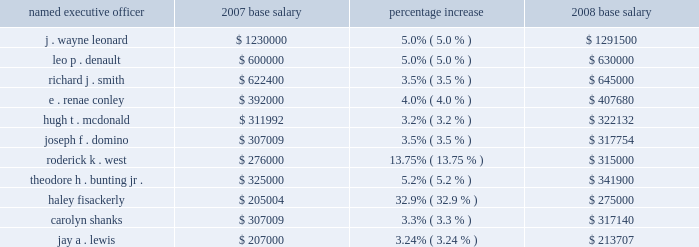The committee's assessment of other elements of compensation provided to the named executive officer .
The corporate and business unit goals and objectives vary by individual officers and include , among other things , corporate and business unit financial performance , capital expenditures , cost containment , safety , reliability , customer service , business development and regulatory matters .
The use of "internal pay equity" in setting merit increases is limited to determining whether a change in an executive officer's role and responsibilities relative to other executive officers requires an adjustment in the officer's salary .
The committee has not established any predetermined formula against which the base salary of one named executive officer is measured against another officer or employee .
In 2008 , on the basis of the market data and other factors described above , merit-based salary increases for the named executive officers were approved in amounts ranging from 3.2 to 5.2 percent .
In general these merit-based increases were consistent with the merit increase percentages approved with respect to named executive officers in the last two years ( excluding adjustments in salaries related to market factors , promotions or other changes in job responsibilities ) .
The table sets forth the 2007 base salaries for the named executive officers , the 2008 percentage increase and the resulting 2008 base salary .
Except as described below , changes in base salaries were effective in april of each of the years shown .
Named executive officer 2007 base salary percentage increase 2008 base salary .
In addition to the market-based and other factors described above , the following factors were considered by the committee with respect to the officers identified below : mr .
Leonard's salary was increased due to the personnel committee's assessment of , among other things , his strong performance as chief executive officer of entergy corporation , entergy corporation's financial and operational performance in 2007 and comparative market data on base salaries for chief executive officers .
In may , 2008 , carolyn shanks resigned as ceo - entergy mississippi and accepted a conditional offer of employment at enexus energy corporation .
Upon her resignation , mr .
Fisackerly was promoted to president and ceo of entergy mississippi , and mr .
Fisackerly's salary was increased to reflect the increased responsibilities of his new position and comparative market and internal data for officers holding similar positions and performing similar responsibilities .
In the third quarter of 2008 , mr .
Bunting took on the role of principal financial officer for the subsidiaries replacing mr .
Lewis in that position .
In the third quarter of 2008 , mr .
Lewis assumed a position with enexus energy corporation .
Mr .
West's salary was increased to reflect his performance as ceo - entergy new orleans , the strategic challenges facing entergy new orleans and the importance of retaining mr .
West to manage these challenges and to retain internal competitiveness of mr .
West's salary with officers in the company holding similar positions. .
What is the difference between the highest and the lowest base salary in 2007? 
Computations: (1230000 - 205004)
Answer: 1024996.0. The committee's assessment of other elements of compensation provided to the named executive officer .
The corporate and business unit goals and objectives vary by individual officers and include , among other things , corporate and business unit financial performance , capital expenditures , cost containment , safety , reliability , customer service , business development and regulatory matters .
The use of "internal pay equity" in setting merit increases is limited to determining whether a change in an executive officer's role and responsibilities relative to other executive officers requires an adjustment in the officer's salary .
The committee has not established any predetermined formula against which the base salary of one named executive officer is measured against another officer or employee .
In 2008 , on the basis of the market data and other factors described above , merit-based salary increases for the named executive officers were approved in amounts ranging from 3.2 to 5.2 percent .
In general these merit-based increases were consistent with the merit increase percentages approved with respect to named executive officers in the last two years ( excluding adjustments in salaries related to market factors , promotions or other changes in job responsibilities ) .
The table sets forth the 2007 base salaries for the named executive officers , the 2008 percentage increase and the resulting 2008 base salary .
Except as described below , changes in base salaries were effective in april of each of the years shown .
Named executive officer 2007 base salary percentage increase 2008 base salary .
In addition to the market-based and other factors described above , the following factors were considered by the committee with respect to the officers identified below : mr .
Leonard's salary was increased due to the personnel committee's assessment of , among other things , his strong performance as chief executive officer of entergy corporation , entergy corporation's financial and operational performance in 2007 and comparative market data on base salaries for chief executive officers .
In may , 2008 , carolyn shanks resigned as ceo - entergy mississippi and accepted a conditional offer of employment at enexus energy corporation .
Upon her resignation , mr .
Fisackerly was promoted to president and ceo of entergy mississippi , and mr .
Fisackerly's salary was increased to reflect the increased responsibilities of his new position and comparative market and internal data for officers holding similar positions and performing similar responsibilities .
In the third quarter of 2008 , mr .
Bunting took on the role of principal financial officer for the subsidiaries replacing mr .
Lewis in that position .
In the third quarter of 2008 , mr .
Lewis assumed a position with enexus energy corporation .
Mr .
West's salary was increased to reflect his performance as ceo - entergy new orleans , the strategic challenges facing entergy new orleans and the importance of retaining mr .
West to manage these challenges and to retain internal competitiveness of mr .
West's salary with officers in the company holding similar positions. .
What is the difference between the highest and the lowest base salary in 2008? 
Computations: (1291500 - 213707)
Answer: 1077793.0. 